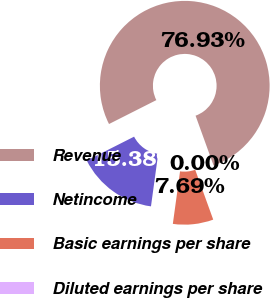Convert chart to OTSL. <chart><loc_0><loc_0><loc_500><loc_500><pie_chart><fcel>Revenue<fcel>Netincome<fcel>Basic earnings per share<fcel>Diluted earnings per share<nl><fcel>76.92%<fcel>15.38%<fcel>7.69%<fcel>0.0%<nl></chart> 